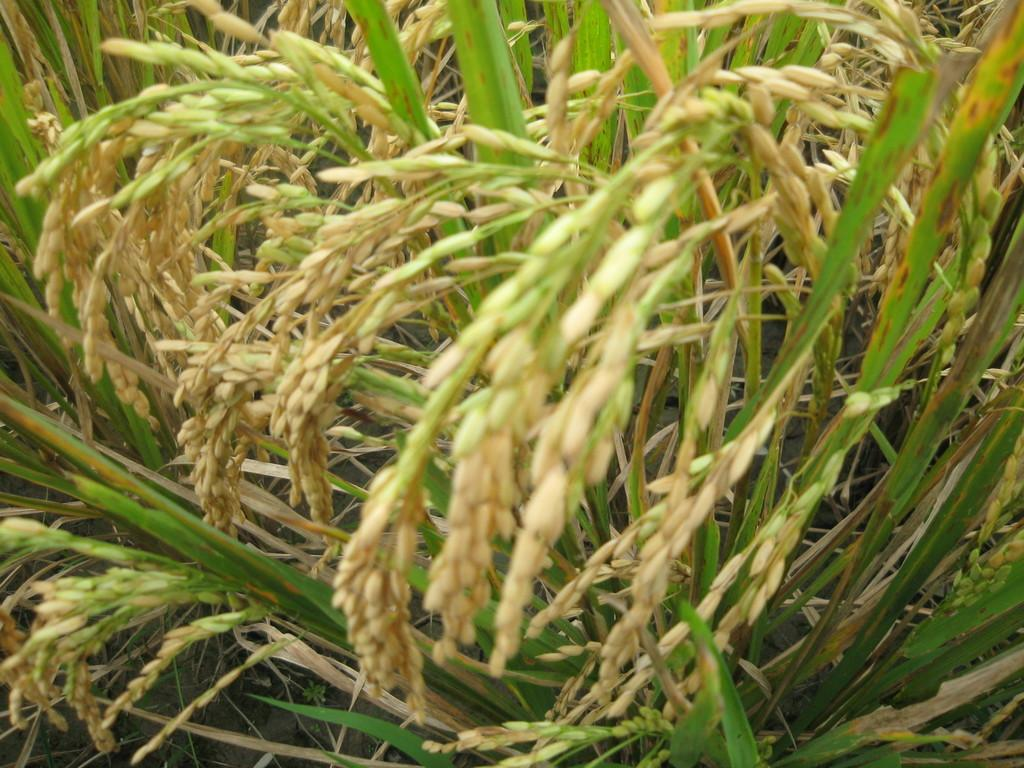What type of crops can be seen in the image? There are paddy crops in the image. How many chickens are sitting on the cork in the image? There are no chickens or cork present in the image; it only features paddy crops. 